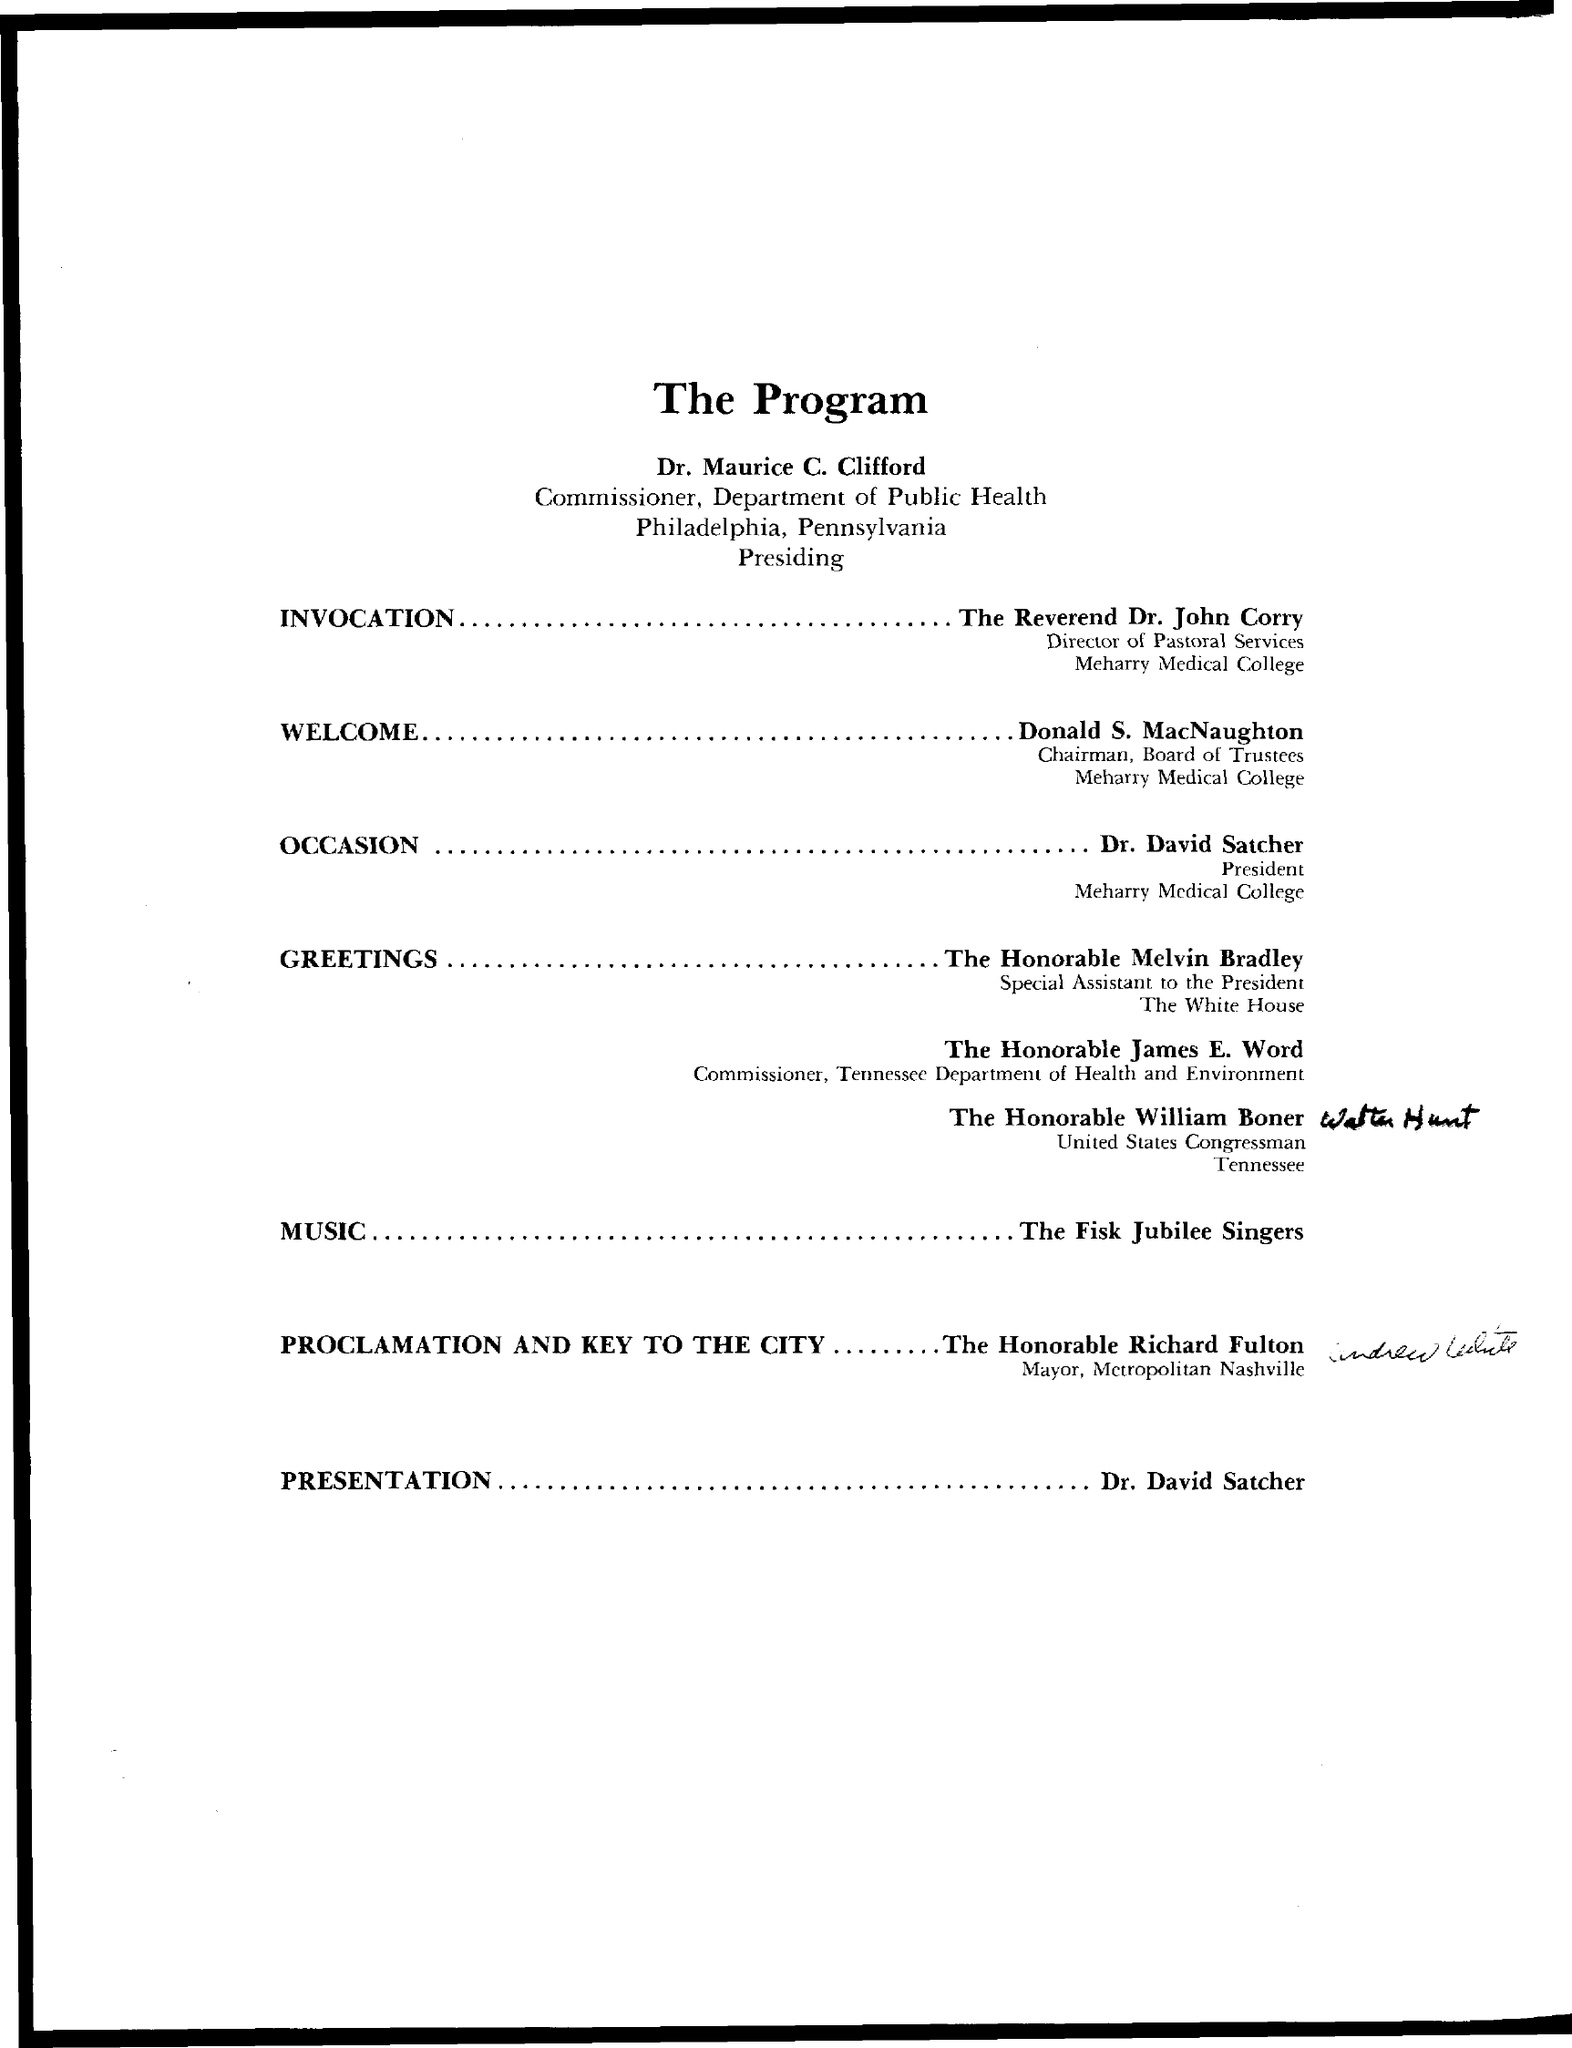Point out several critical features in this image. The title of the document is 'What is the title of the document? The Program...'. 